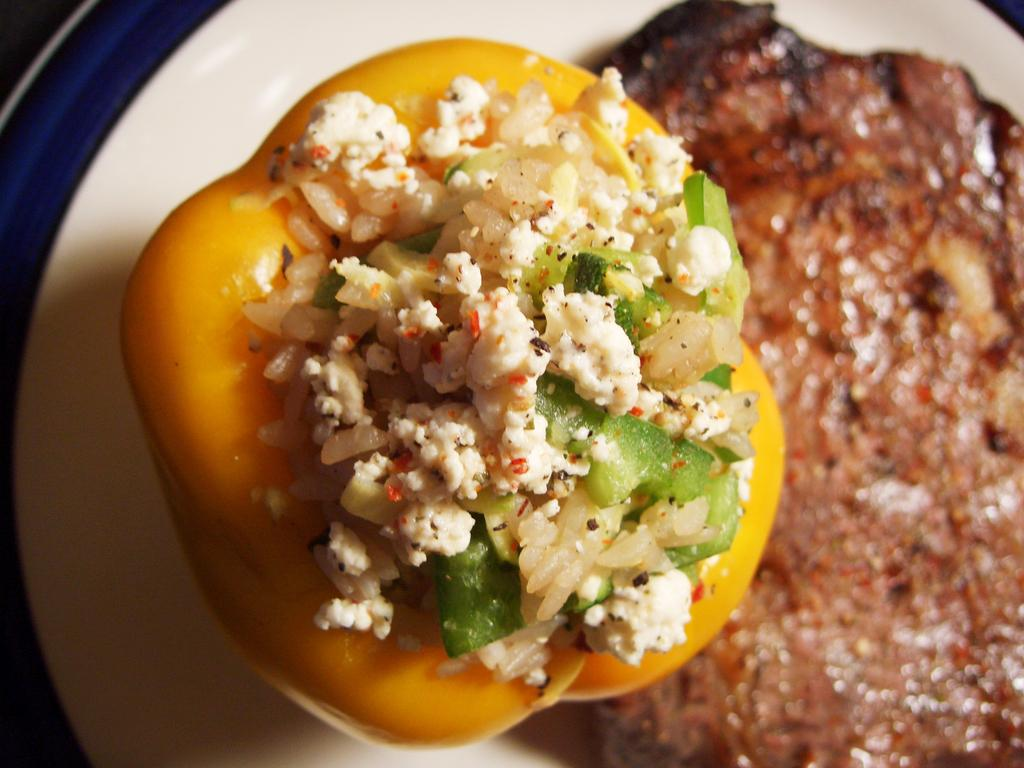What is on the plate that is visible in the image? There is food on a plate in the image. What colors can be seen in the image? The colors white and blue are present in the image. How many hands are visible in the image? There are no hands visible in the image. What day of the week is it in the image? The day of the week is not mentioned or depicted in the image. 